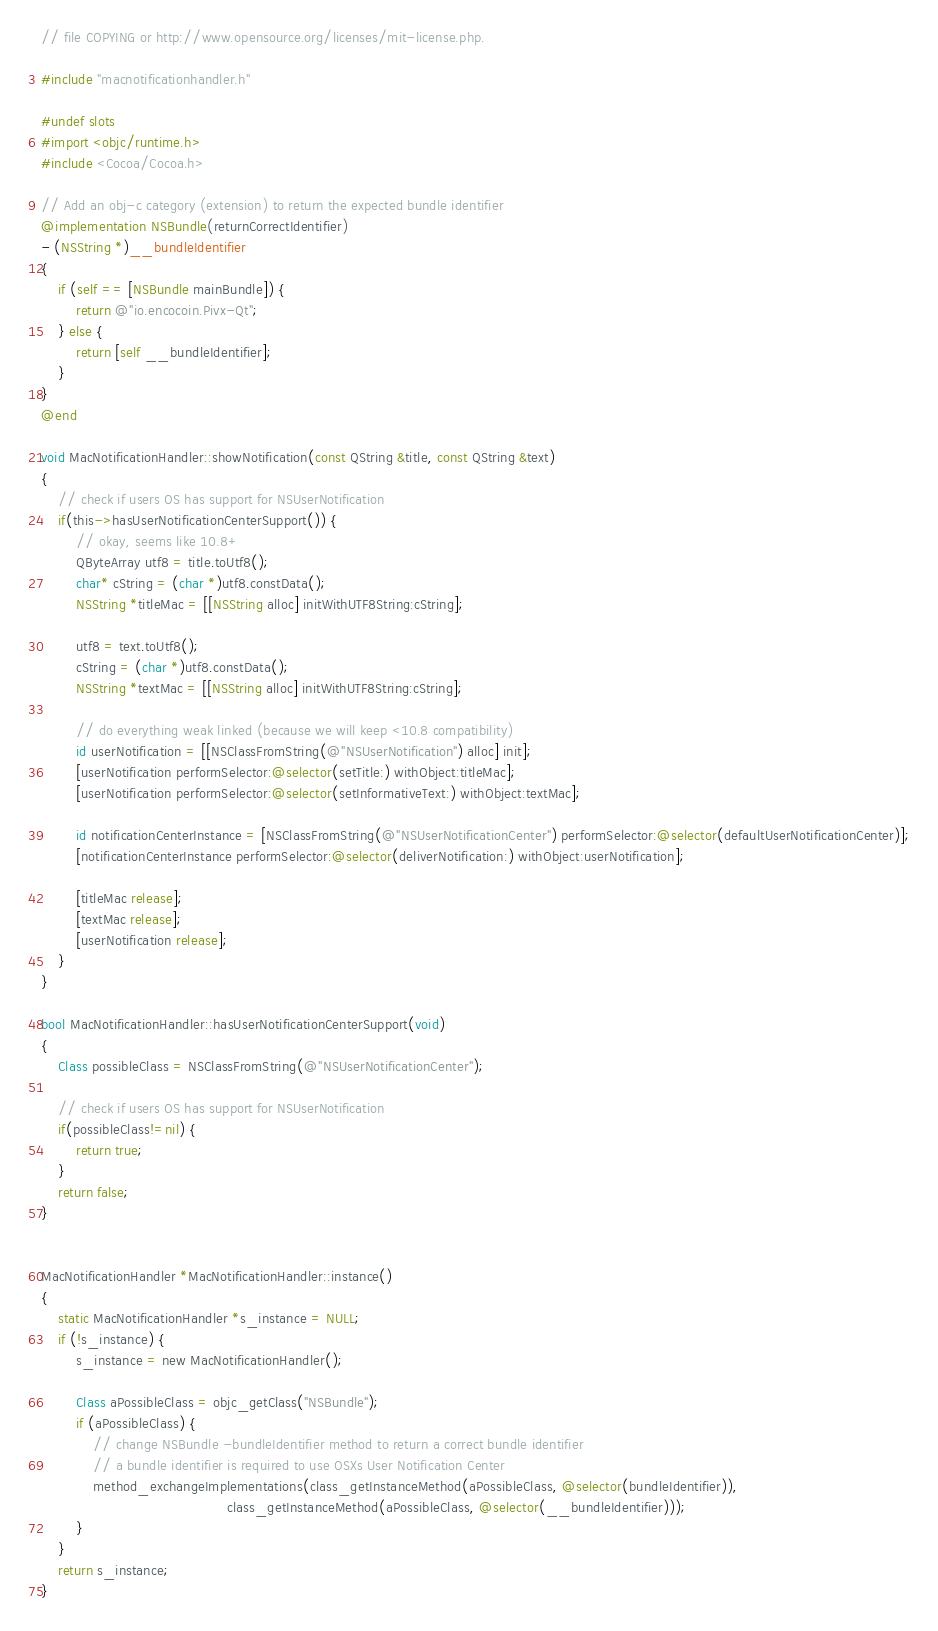Convert code to text. <code><loc_0><loc_0><loc_500><loc_500><_ObjectiveC_>// file COPYING or http://www.opensource.org/licenses/mit-license.php.

#include "macnotificationhandler.h"

#undef slots
#import <objc/runtime.h>
#include <Cocoa/Cocoa.h>

// Add an obj-c category (extension) to return the expected bundle identifier
@implementation NSBundle(returnCorrectIdentifier)
- (NSString *)__bundleIdentifier
{
    if (self == [NSBundle mainBundle]) {
        return @"io.encocoin.Pivx-Qt";
    } else {
        return [self __bundleIdentifier];
    }
}
@end

void MacNotificationHandler::showNotification(const QString &title, const QString &text)
{
    // check if users OS has support for NSUserNotification
    if(this->hasUserNotificationCenterSupport()) {
        // okay, seems like 10.8+
        QByteArray utf8 = title.toUtf8();
        char* cString = (char *)utf8.constData();
        NSString *titleMac = [[NSString alloc] initWithUTF8String:cString];

        utf8 = text.toUtf8();
        cString = (char *)utf8.constData();
        NSString *textMac = [[NSString alloc] initWithUTF8String:cString];

        // do everything weak linked (because we will keep <10.8 compatibility)
        id userNotification = [[NSClassFromString(@"NSUserNotification") alloc] init];
        [userNotification performSelector:@selector(setTitle:) withObject:titleMac];
        [userNotification performSelector:@selector(setInformativeText:) withObject:textMac];

        id notificationCenterInstance = [NSClassFromString(@"NSUserNotificationCenter") performSelector:@selector(defaultUserNotificationCenter)];
        [notificationCenterInstance performSelector:@selector(deliverNotification:) withObject:userNotification];

        [titleMac release];
        [textMac release];
        [userNotification release];
    }
}

bool MacNotificationHandler::hasUserNotificationCenterSupport(void)
{
    Class possibleClass = NSClassFromString(@"NSUserNotificationCenter");

    // check if users OS has support for NSUserNotification
    if(possibleClass!=nil) {
        return true;
    }
    return false;
}


MacNotificationHandler *MacNotificationHandler::instance()
{
    static MacNotificationHandler *s_instance = NULL;
    if (!s_instance) {
        s_instance = new MacNotificationHandler();
        
        Class aPossibleClass = objc_getClass("NSBundle");
        if (aPossibleClass) {
            // change NSBundle -bundleIdentifier method to return a correct bundle identifier
            // a bundle identifier is required to use OSXs User Notification Center
            method_exchangeImplementations(class_getInstanceMethod(aPossibleClass, @selector(bundleIdentifier)),
                                           class_getInstanceMethod(aPossibleClass, @selector(__bundleIdentifier)));
        }
    }
    return s_instance;
}
</code> 